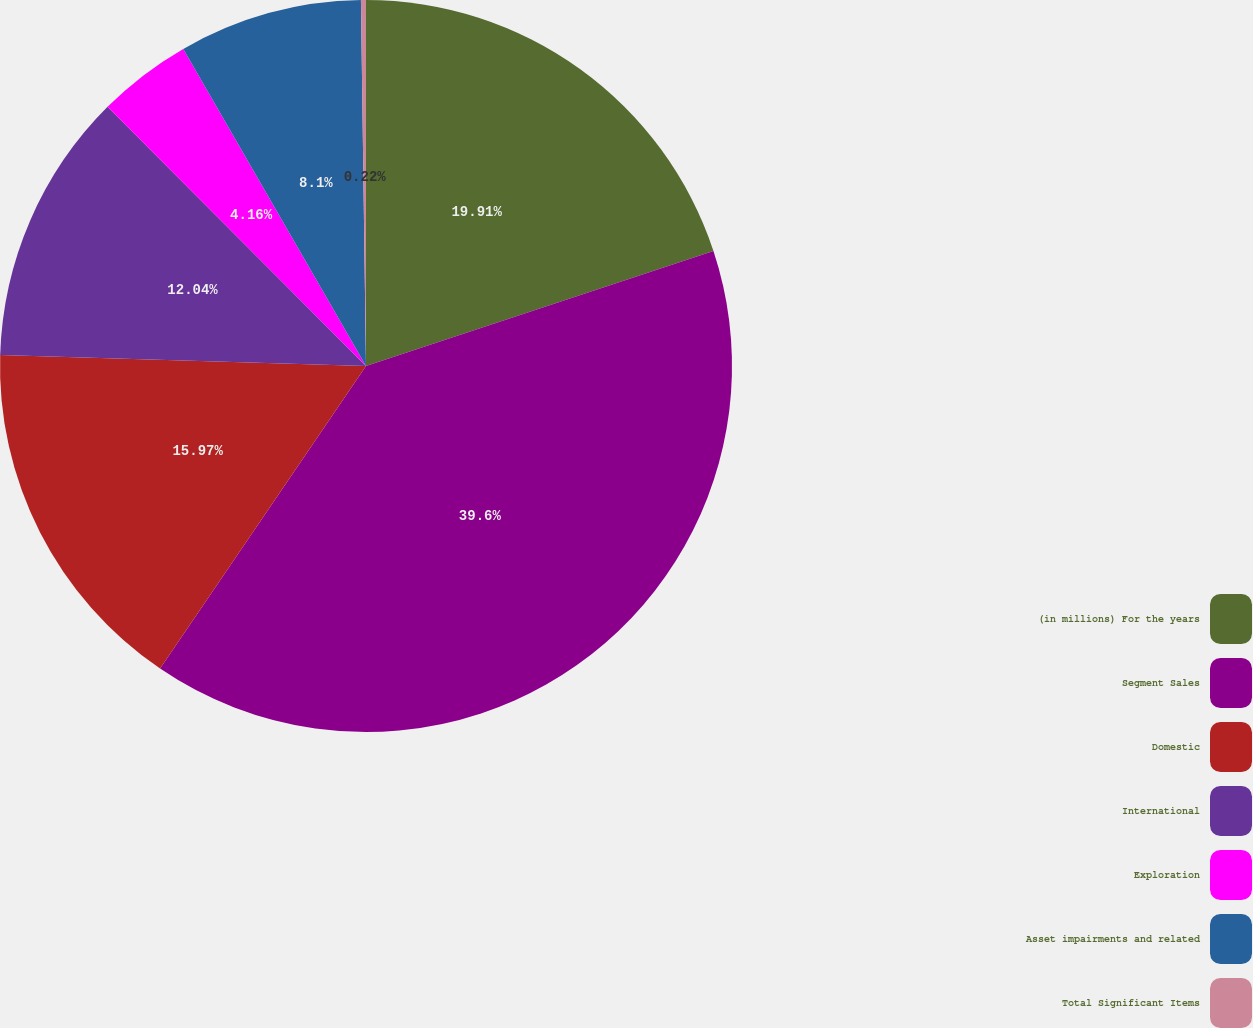Convert chart. <chart><loc_0><loc_0><loc_500><loc_500><pie_chart><fcel>(in millions) For the years<fcel>Segment Sales<fcel>Domestic<fcel>International<fcel>Exploration<fcel>Asset impairments and related<fcel>Total Significant Items<nl><fcel>19.91%<fcel>39.6%<fcel>15.97%<fcel>12.04%<fcel>4.16%<fcel>8.1%<fcel>0.22%<nl></chart> 